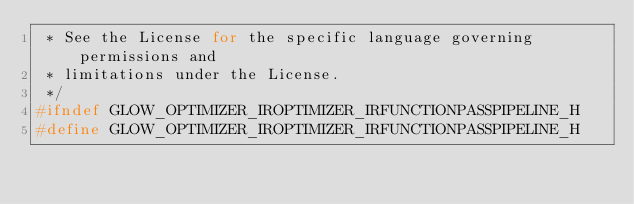<code> <loc_0><loc_0><loc_500><loc_500><_C_> * See the License for the specific language governing permissions and
 * limitations under the License.
 */
#ifndef GLOW_OPTIMIZER_IROPTIMIZER_IRFUNCTIONPASSPIPELINE_H
#define GLOW_OPTIMIZER_IROPTIMIZER_IRFUNCTIONPASSPIPELINE_H
</code> 